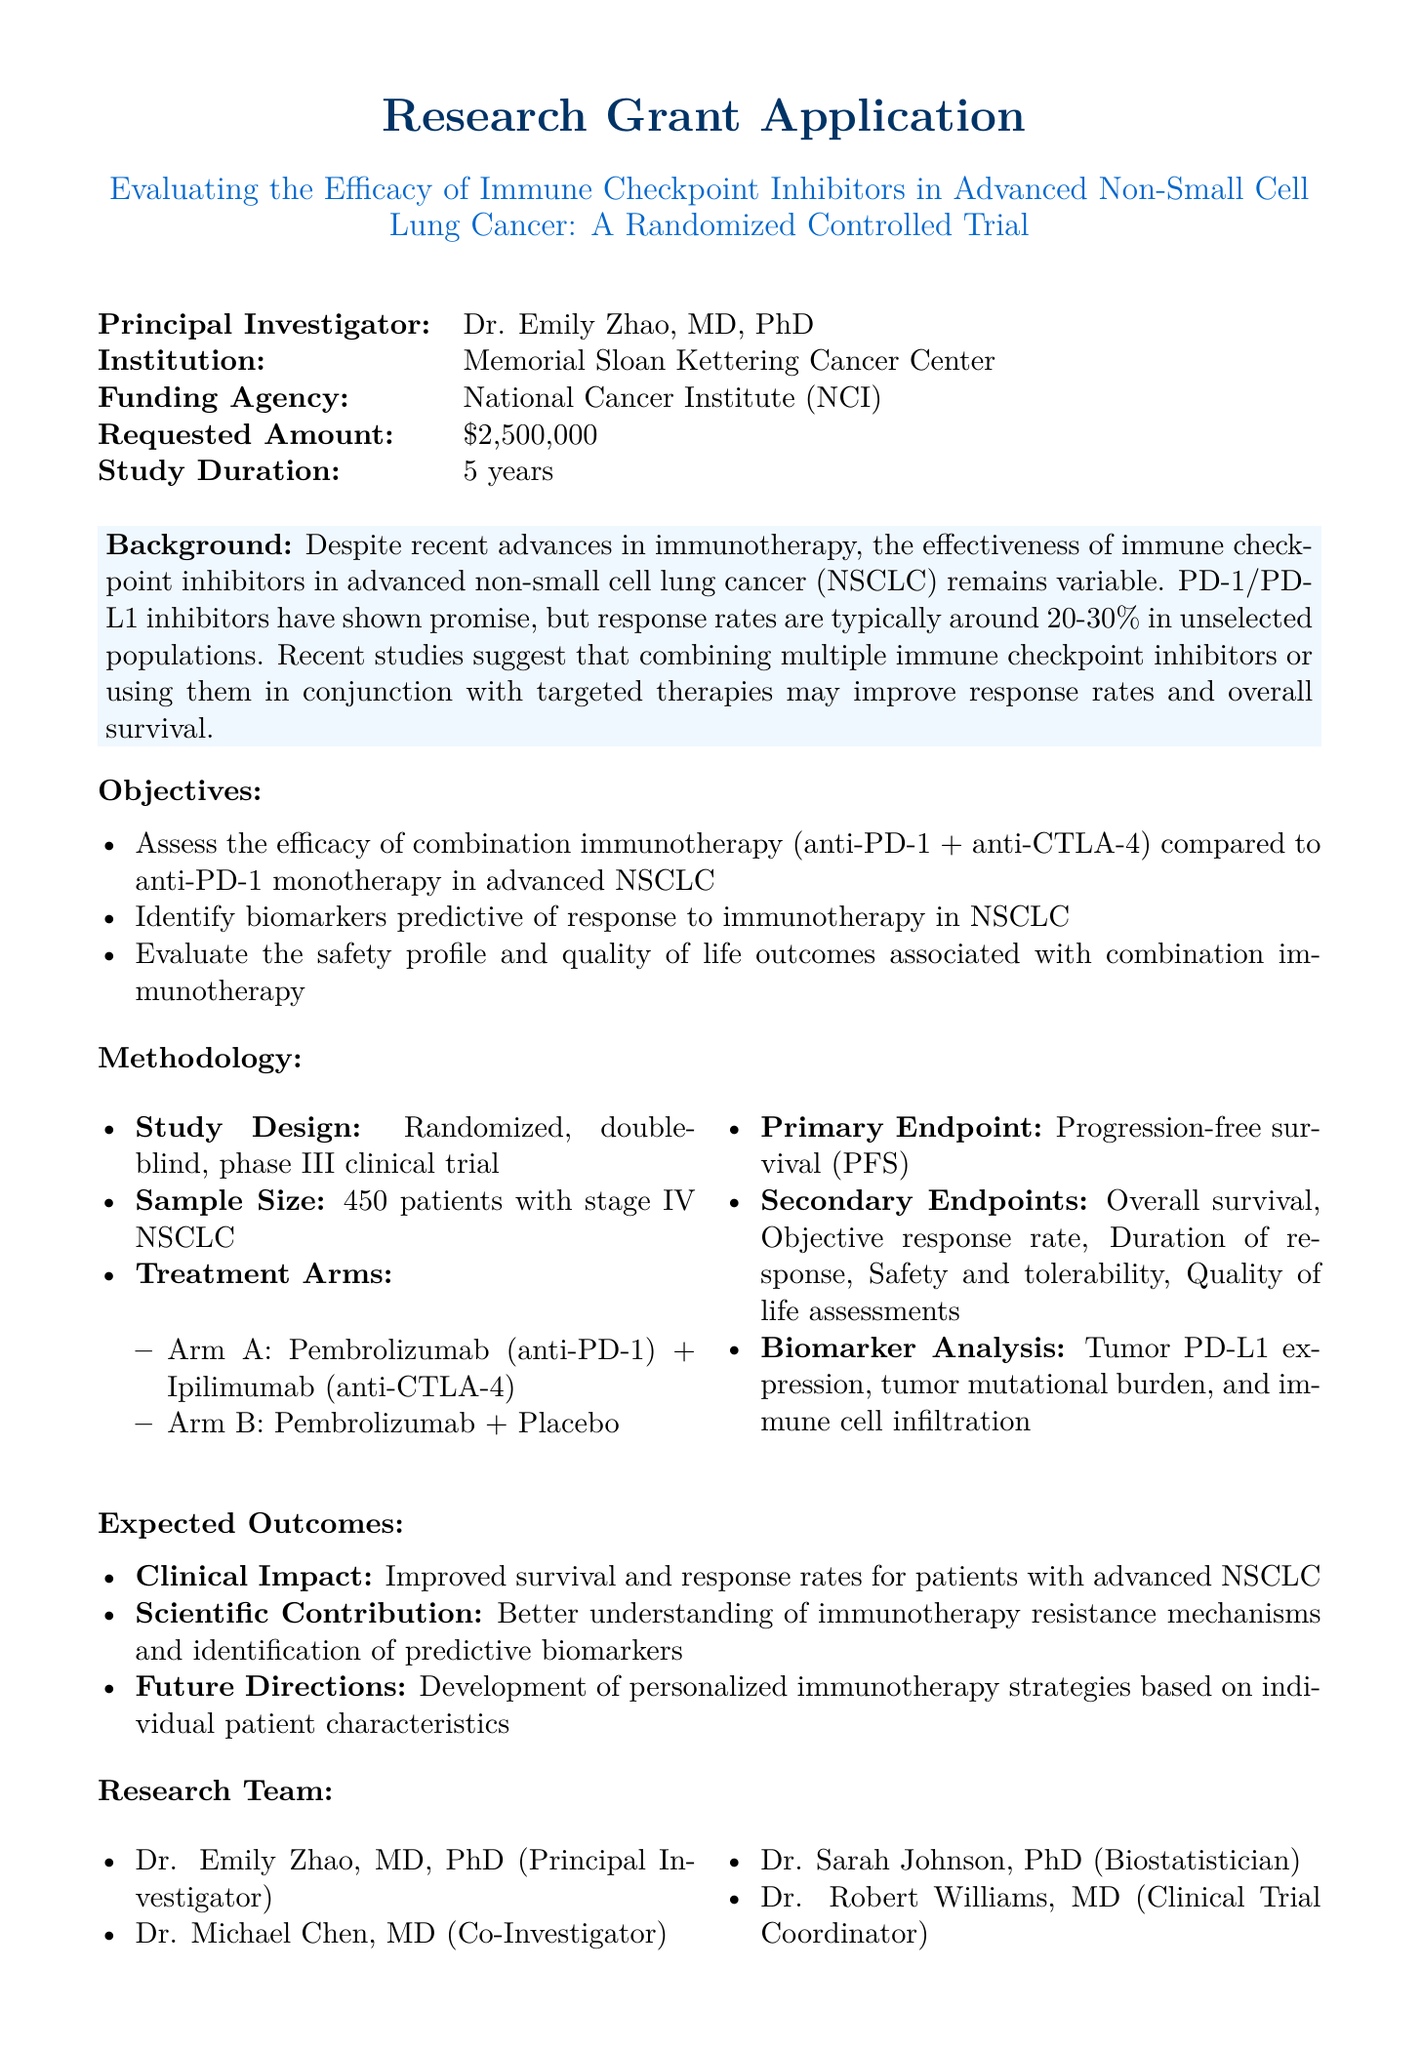What is the title of the study? The title summarizes the focus of the research, which is to evaluate the effectiveness of immune checkpoint inhibitors in lung cancer.
Answer: Evaluating the Efficacy of Immune Checkpoint Inhibitors in Advanced Non-Small Cell Lung Cancer: A Randomized Controlled Trial Who is the principal investigator? The principal investigator is the lead researcher responsible for the study, identified in the document.
Answer: Dr. Emily Zhao, MD, PhD What is the requested amount for the grant? The requested amount reflects the total funding needed for the study, as specified in the budget section.
Answer: $2,500,000 How many patients will be included in the study? This number represents the sample size necessary for obtaining statistically significant results from the trial.
Answer: 450 patients What is the primary endpoint of the trial? The primary endpoint is the main outcome measure the researchers are looking to assess through the clinical trial.
Answer: Progression-free survival (PFS) What are the treatment arms in the trial? The treatment arms detail the specific interventions being tested in the clinical trial.
Answer: Arm A: Pembrolizumab (anti-PD-1) + Ipilimumab (anti-CTLA-4); Arm B: Pembrolizumab + Placebo What ethical approval is mentioned? This refers to the institutional oversight necessary to ensure the study meets ethical standards.
Answer: IRB approval pending from Memorial Sloan Kettering Cancer Center What is one expected outcome of the study? This question explores the potential impacts of the trial findings regarding patient care or scientific knowledge.
Answer: Improved survival and response rates for patients with advanced NSCLC What aspect does the research focus on? This indicates the specific component of cancer treatment the study is addressing and the research design which incorporates established therapies.
Answer: Well-established immunotherapy agents with proven mechanisms of action 